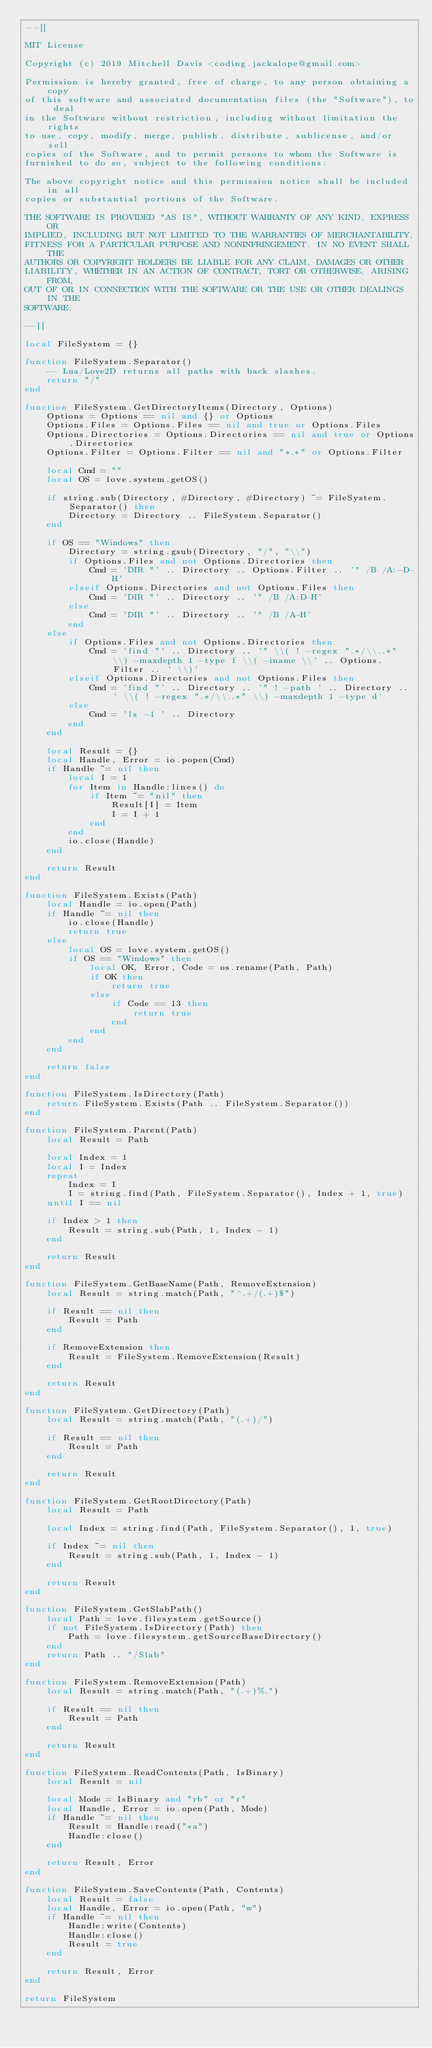Convert code to text. <code><loc_0><loc_0><loc_500><loc_500><_Lua_>--[[

MIT License

Copyright (c) 2019 Mitchell Davis <coding.jackalope@gmail.com>

Permission is hereby granted, free of charge, to any person obtaining a copy
of this software and associated documentation files (the "Software"), to deal
in the Software without restriction, including without limitation the rights
to use, copy, modify, merge, publish, distribute, sublicense, and/or sell
copies of the Software, and to permit persons to whom the Software is
furnished to do so, subject to the following conditions:

The above copyright notice and this permission notice shall be included in all
copies or substantial portions of the Software.

THE SOFTWARE IS PROVIDED "AS IS", WITHOUT WARRANTY OF ANY KIND, EXPRESS OR
IMPLIED, INCLUDING BUT NOT LIMITED TO THE WARRANTIES OF MERCHANTABILITY,
FITNESS FOR A PARTICULAR PURPOSE AND NONINFRINGEMENT. IN NO EVENT SHALL THE
AUTHORS OR COPYRIGHT HOLDERS BE LIABLE FOR ANY CLAIM, DAMAGES OR OTHER
LIABILITY, WHETHER IN AN ACTION OF CONTRACT, TORT OR OTHERWISE, ARISING FROM,
OUT OF OR IN CONNECTION WITH THE SOFTWARE OR THE USE OR OTHER DEALINGS IN THE
SOFTWARE.

--]]

local FileSystem = {}

function FileSystem.Separator()
	-- Lua/Love2D returns all paths with back slashes.
	return "/"
end

function FileSystem.GetDirectoryItems(Directory, Options)
	Options = Options == nil and {} or Options
	Options.Files = Options.Files == nil and true or Options.Files
	Options.Directories = Options.Directories == nil and true or Options.Directories
	Options.Filter = Options.Filter == nil and "*.*" or Options.Filter

	local Cmd = ""
	local OS = love.system.getOS()

	if string.sub(Directory, #Directory, #Directory) ~= FileSystem.Separator() then
		Directory = Directory .. FileSystem.Separator()
	end

	if OS == "Windows" then
		Directory = string.gsub(Directory, "/", "\\")
		if Options.Files and not Options.Directories then
			Cmd = 'DIR "' .. Directory .. Options.Filter .. '" /B /A:-D-H'
		elseif Options.Directories and not Options.Files then
			Cmd = 'DIR "' .. Directory .. '" /B /A:D-H'
		else
			Cmd = 'DIR "' .. Directory .. '" /B /A-H'
		end
	else
		if Options.Files and not Options.Directories then
			Cmd = 'find "' .. Directory .. '" \\( ! -regex ".*/\\..*" \\) -maxdepth 1 -type f \\( -iname \\' .. Options.Filter .. ' \\)'
		elseif Options.Directories and not Options.Files then
			Cmd = 'find "' .. Directory .. '" ! -path ' .. Directory .. ' \\( ! -regex ".*/\\..*" \\) -maxdepth 1 -type d'
		else
			Cmd = 'ls -1 ' .. Directory
		end
	end

	local Result = {}
	local Handle, Error = io.popen(Cmd)
	if Handle ~= nil then
		local I = 1
		for Item in Handle:lines() do
			if Item ~= "nil" then
				Result[I] = Item
				I = I + 1
			end
		end
		io.close(Handle)
	end

	return Result
end

function FileSystem.Exists(Path)
	local Handle = io.open(Path)
	if Handle ~= nil then
		io.close(Handle)
		return true
	else
		local OS = love.system.getOS()
		if OS == "Windows" then
			local OK, Error, Code = os.rename(Path, Path)
			if OK then
				return true
			else
				if Code == 13 then
					return true
				end
			end
		end
	end

	return false
end

function FileSystem.IsDirectory(Path)
	return FileSystem.Exists(Path .. FileSystem.Separator())
end

function FileSystem.Parent(Path)
	local Result = Path

	local Index = 1
	local I = Index
	repeat
		Index = I
		I = string.find(Path, FileSystem.Separator(), Index + 1, true)
	until I == nil

	if Index > 1 then
		Result = string.sub(Path, 1, Index - 1)
	end

	return Result
end

function FileSystem.GetBaseName(Path, RemoveExtension)
	local Result = string.match(Path, "^.+/(.+)$")

	if Result == nil then
		Result = Path
	end

	if RemoveExtension then
		Result = FileSystem.RemoveExtension(Result)
	end

	return Result
end

function FileSystem.GetDirectory(Path)
	local Result = string.match(Path, "(.+)/")

	if Result == nil then
		Result = Path
	end

	return Result
end

function FileSystem.GetRootDirectory(Path)
	local Result = Path

	local Index = string.find(Path, FileSystem.Separator(), 1, true)

	if Index ~= nil then
		Result = string.sub(Path, 1, Index - 1)
	end

	return Result
end

function FileSystem.GetSlabPath()
	local Path = love.filesystem.getSource()
	if not FileSystem.IsDirectory(Path) then
		Path = love.filesystem.getSourceBaseDirectory()
	end
	return Path .. "/Slab"
end

function FileSystem.RemoveExtension(Path)
	local Result = string.match(Path, "(.+)%.")

	if Result == nil then
		Result = Path
	end

	return Result
end

function FileSystem.ReadContents(Path, IsBinary)
	local Result = nil

	local Mode = IsBinary and "rb" or "r"
	local Handle, Error = io.open(Path, Mode)
	if Handle ~= nil then
		Result = Handle:read("*a")
		Handle:close()
	end

	return Result, Error
end

function FileSystem.SaveContents(Path, Contents)
	local Result = false
	local Handle, Error = io.open(Path, "w")
	if Handle ~= nil then
		Handle:write(Contents)
		Handle:close()
		Result = true
	end

	return Result, Error
end

return FileSystem
</code> 